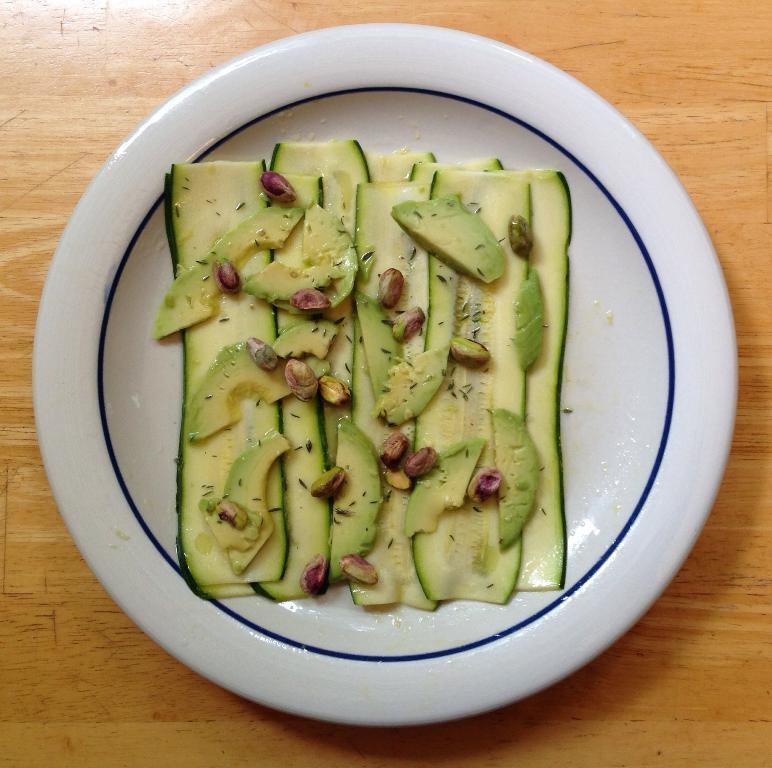What is on the plate that is visible in the image? The plate contains chopped fruits and groundnuts. What color is the plate in the image? The plate is white. Where is the plate placed in the image? The plate is placed on a brown table. What type of drug is present on the plate in the image? There is no drug present on the plate in the image; it contains chopped fruits and groundnuts. 